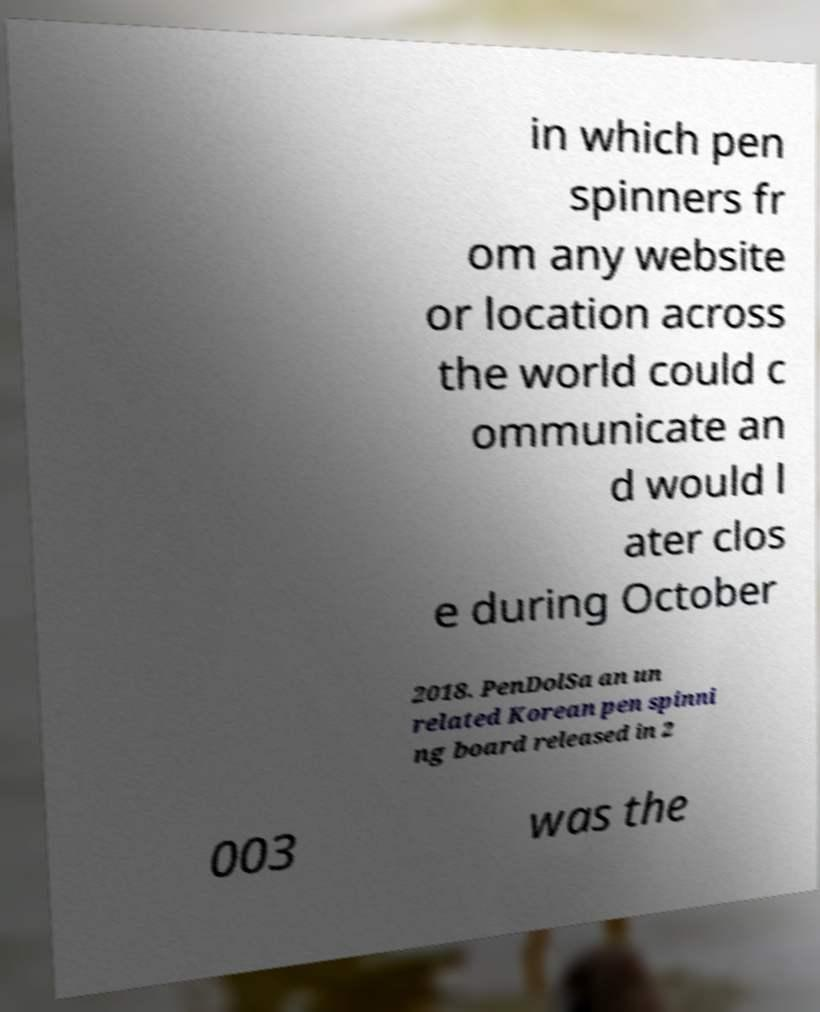Please identify and transcribe the text found in this image. in which pen spinners fr om any website or location across the world could c ommunicate an d would l ater clos e during October 2018. PenDolSa an un related Korean pen spinni ng board released in 2 003 was the 